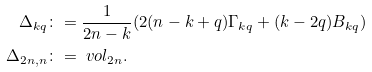<formula> <loc_0><loc_0><loc_500><loc_500>\Delta _ { k q } \colon & = \frac { 1 } { 2 n - k } ( 2 ( n - k + q ) \Gamma _ { k q } + ( k - 2 q ) B _ { k q } ) \\ \Delta _ { 2 n , n } \colon & = \ v o l _ { 2 n } .</formula> 